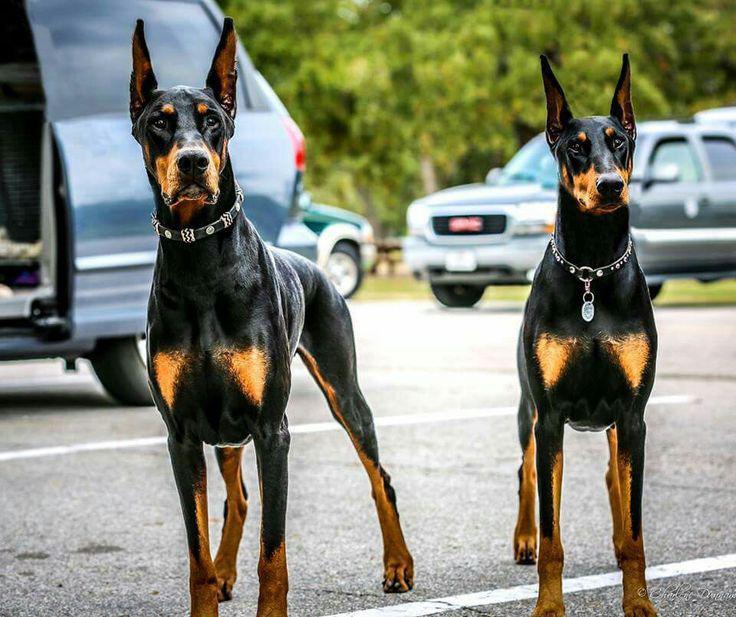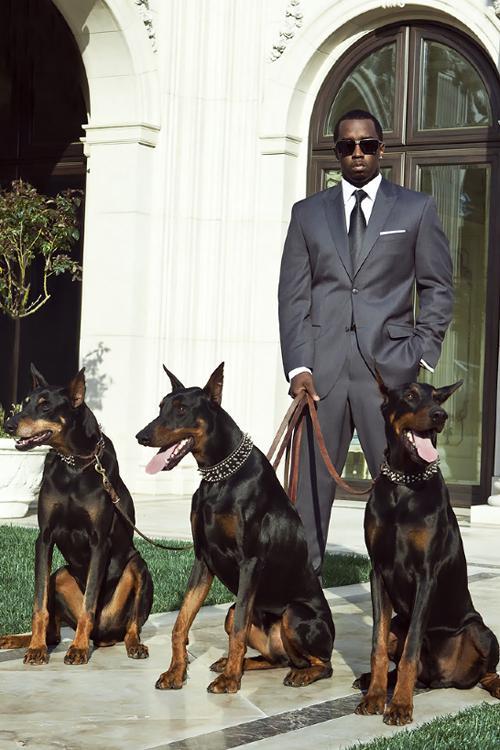The first image is the image on the left, the second image is the image on the right. Considering the images on both sides, is "There are three dogs sitting down." valid? Answer yes or no. Yes. The first image is the image on the left, the second image is the image on the right. For the images displayed, is the sentence "The right image contains exactly three doberman dogs with erect pointy ears wearing leashes and collars." factually correct? Answer yes or no. Yes. 